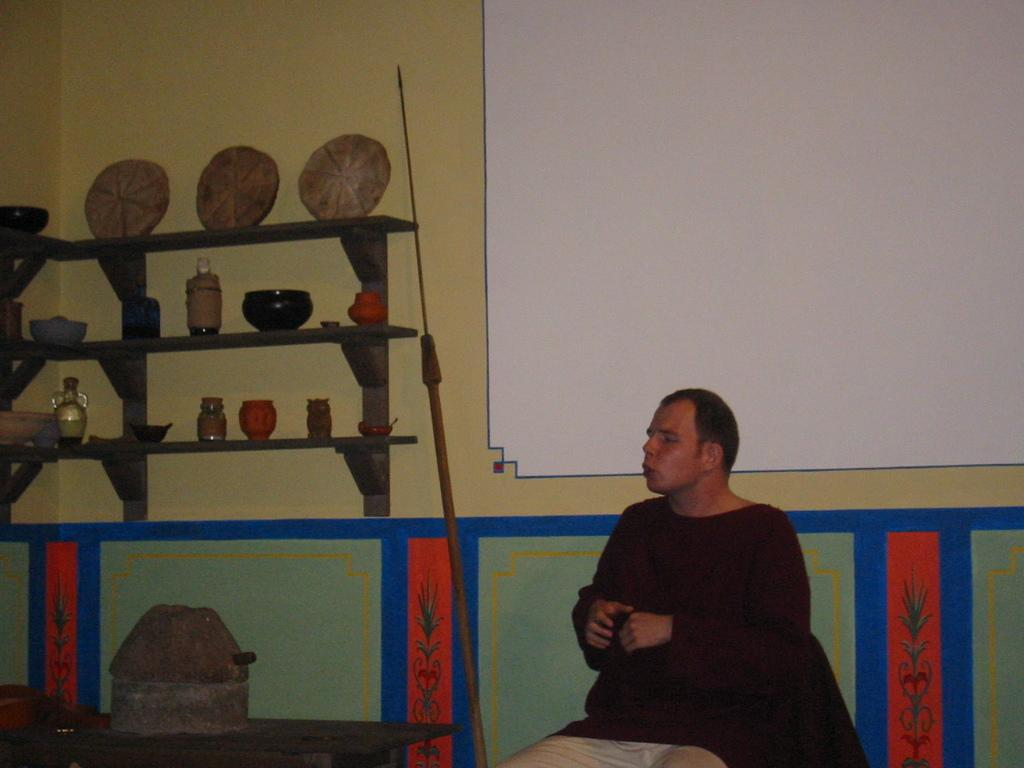What is the man in the image doing? The man is seated in the image. What can be seen on the shelves in the image? There are bottles and bowls on the shelves in the image. What is on the table in the image? There appears to be a vessel on the table in the image. What type of question is the man asking in the image? There is no indication in the image that the man is asking a question. How many feet can be seen in the image? The image does not show any feet; it only shows a man seated and objects on shelves and a table. 